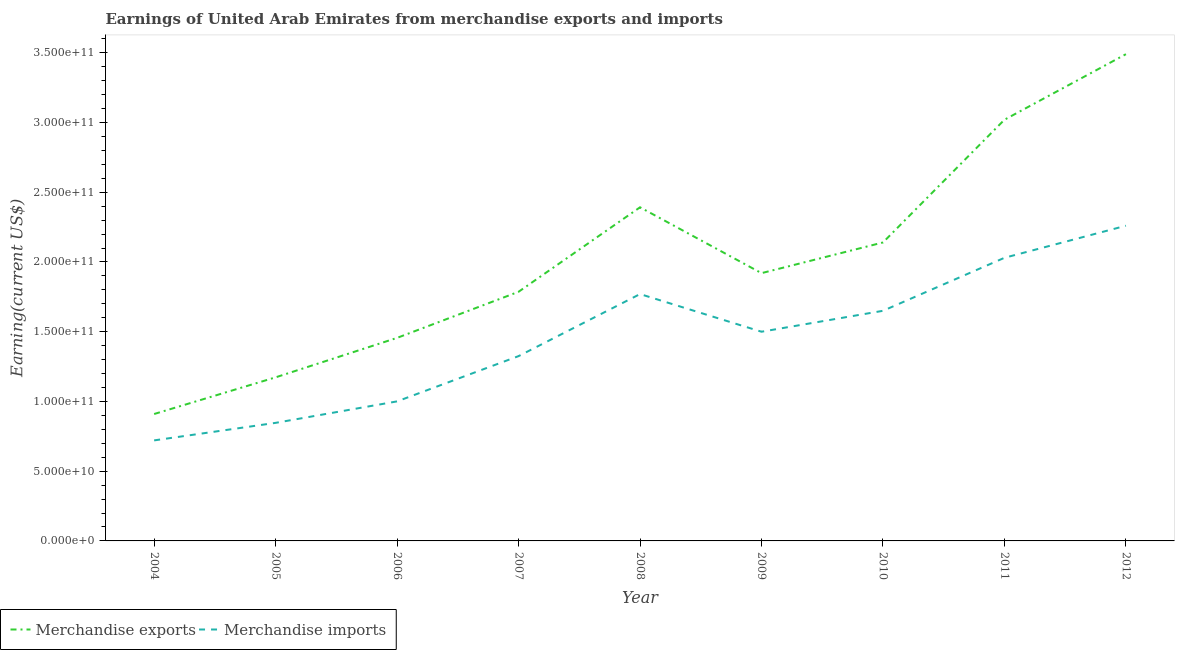How many different coloured lines are there?
Ensure brevity in your answer.  2. Does the line corresponding to earnings from merchandise exports intersect with the line corresponding to earnings from merchandise imports?
Make the answer very short. No. Is the number of lines equal to the number of legend labels?
Keep it short and to the point. Yes. What is the earnings from merchandise imports in 2006?
Provide a short and direct response. 1.00e+11. Across all years, what is the maximum earnings from merchandise exports?
Make the answer very short. 3.49e+11. Across all years, what is the minimum earnings from merchandise imports?
Provide a short and direct response. 7.21e+1. In which year was the earnings from merchandise exports maximum?
Provide a succinct answer. 2012. In which year was the earnings from merchandise imports minimum?
Provide a succinct answer. 2004. What is the total earnings from merchandise exports in the graph?
Your answer should be compact. 1.83e+12. What is the difference between the earnings from merchandise imports in 2004 and that in 2010?
Provide a succinct answer. -9.29e+1. What is the difference between the earnings from merchandise imports in 2012 and the earnings from merchandise exports in 2008?
Provide a short and direct response. -1.32e+1. What is the average earnings from merchandise exports per year?
Give a very brief answer. 2.03e+11. In the year 2008, what is the difference between the earnings from merchandise exports and earnings from merchandise imports?
Provide a short and direct response. 6.22e+1. What is the ratio of the earnings from merchandise exports in 2006 to that in 2007?
Give a very brief answer. 0.82. What is the difference between the highest and the second highest earnings from merchandise imports?
Keep it short and to the point. 2.30e+1. What is the difference between the highest and the lowest earnings from merchandise imports?
Make the answer very short. 1.54e+11. In how many years, is the earnings from merchandise exports greater than the average earnings from merchandise exports taken over all years?
Give a very brief answer. 4. Is the sum of the earnings from merchandise imports in 2007 and 2010 greater than the maximum earnings from merchandise exports across all years?
Your answer should be compact. No. Does the earnings from merchandise imports monotonically increase over the years?
Offer a very short reply. No. What is the difference between two consecutive major ticks on the Y-axis?
Keep it short and to the point. 5.00e+1. How many legend labels are there?
Make the answer very short. 2. How are the legend labels stacked?
Your response must be concise. Horizontal. What is the title of the graph?
Your answer should be very brief. Earnings of United Arab Emirates from merchandise exports and imports. Does "Agricultural land" appear as one of the legend labels in the graph?
Ensure brevity in your answer.  No. What is the label or title of the X-axis?
Make the answer very short. Year. What is the label or title of the Y-axis?
Offer a very short reply. Earning(current US$). What is the Earning(current US$) in Merchandise exports in 2004?
Offer a terse response. 9.10e+1. What is the Earning(current US$) of Merchandise imports in 2004?
Your answer should be very brief. 7.21e+1. What is the Earning(current US$) of Merchandise exports in 2005?
Give a very brief answer. 1.17e+11. What is the Earning(current US$) in Merchandise imports in 2005?
Your response must be concise. 8.47e+1. What is the Earning(current US$) of Merchandise exports in 2006?
Keep it short and to the point. 1.46e+11. What is the Earning(current US$) in Merchandise imports in 2006?
Offer a very short reply. 1.00e+11. What is the Earning(current US$) in Merchandise exports in 2007?
Give a very brief answer. 1.79e+11. What is the Earning(current US$) in Merchandise imports in 2007?
Make the answer very short. 1.32e+11. What is the Earning(current US$) in Merchandise exports in 2008?
Provide a short and direct response. 2.39e+11. What is the Earning(current US$) in Merchandise imports in 2008?
Provide a succinct answer. 1.77e+11. What is the Earning(current US$) in Merchandise exports in 2009?
Give a very brief answer. 1.92e+11. What is the Earning(current US$) in Merchandise imports in 2009?
Offer a terse response. 1.50e+11. What is the Earning(current US$) in Merchandise exports in 2010?
Ensure brevity in your answer.  2.14e+11. What is the Earning(current US$) in Merchandise imports in 2010?
Your answer should be very brief. 1.65e+11. What is the Earning(current US$) in Merchandise exports in 2011?
Provide a short and direct response. 3.02e+11. What is the Earning(current US$) in Merchandise imports in 2011?
Make the answer very short. 2.03e+11. What is the Earning(current US$) in Merchandise exports in 2012?
Provide a succinct answer. 3.49e+11. What is the Earning(current US$) in Merchandise imports in 2012?
Provide a short and direct response. 2.26e+11. Across all years, what is the maximum Earning(current US$) in Merchandise exports?
Provide a short and direct response. 3.49e+11. Across all years, what is the maximum Earning(current US$) of Merchandise imports?
Make the answer very short. 2.26e+11. Across all years, what is the minimum Earning(current US$) in Merchandise exports?
Offer a very short reply. 9.10e+1. Across all years, what is the minimum Earning(current US$) of Merchandise imports?
Give a very brief answer. 7.21e+1. What is the total Earning(current US$) of Merchandise exports in the graph?
Keep it short and to the point. 1.83e+12. What is the total Earning(current US$) in Merchandise imports in the graph?
Provide a succinct answer. 1.31e+12. What is the difference between the Earning(current US$) of Merchandise exports in 2004 and that in 2005?
Offer a terse response. -2.63e+1. What is the difference between the Earning(current US$) in Merchandise imports in 2004 and that in 2005?
Offer a terse response. -1.26e+1. What is the difference between the Earning(current US$) in Merchandise exports in 2004 and that in 2006?
Provide a succinct answer. -5.46e+1. What is the difference between the Earning(current US$) of Merchandise imports in 2004 and that in 2006?
Give a very brief answer. -2.80e+1. What is the difference between the Earning(current US$) of Merchandise exports in 2004 and that in 2007?
Offer a very short reply. -8.76e+1. What is the difference between the Earning(current US$) of Merchandise imports in 2004 and that in 2007?
Ensure brevity in your answer.  -6.04e+1. What is the difference between the Earning(current US$) in Merchandise exports in 2004 and that in 2008?
Your response must be concise. -1.48e+11. What is the difference between the Earning(current US$) of Merchandise imports in 2004 and that in 2008?
Give a very brief answer. -1.05e+11. What is the difference between the Earning(current US$) of Merchandise exports in 2004 and that in 2009?
Ensure brevity in your answer.  -1.01e+11. What is the difference between the Earning(current US$) in Merchandise imports in 2004 and that in 2009?
Give a very brief answer. -7.79e+1. What is the difference between the Earning(current US$) of Merchandise exports in 2004 and that in 2010?
Offer a terse response. -1.23e+11. What is the difference between the Earning(current US$) of Merchandise imports in 2004 and that in 2010?
Keep it short and to the point. -9.29e+1. What is the difference between the Earning(current US$) of Merchandise exports in 2004 and that in 2011?
Provide a succinct answer. -2.11e+11. What is the difference between the Earning(current US$) in Merchandise imports in 2004 and that in 2011?
Give a very brief answer. -1.31e+11. What is the difference between the Earning(current US$) in Merchandise exports in 2004 and that in 2012?
Offer a very short reply. -2.58e+11. What is the difference between the Earning(current US$) of Merchandise imports in 2004 and that in 2012?
Give a very brief answer. -1.54e+11. What is the difference between the Earning(current US$) of Merchandise exports in 2005 and that in 2006?
Ensure brevity in your answer.  -2.83e+1. What is the difference between the Earning(current US$) of Merchandise imports in 2005 and that in 2006?
Your answer should be very brief. -1.54e+1. What is the difference between the Earning(current US$) in Merchandise exports in 2005 and that in 2007?
Give a very brief answer. -6.13e+1. What is the difference between the Earning(current US$) in Merchandise imports in 2005 and that in 2007?
Your response must be concise. -4.78e+1. What is the difference between the Earning(current US$) of Merchandise exports in 2005 and that in 2008?
Your answer should be compact. -1.22e+11. What is the difference between the Earning(current US$) in Merchandise imports in 2005 and that in 2008?
Provide a short and direct response. -9.23e+1. What is the difference between the Earning(current US$) of Merchandise exports in 2005 and that in 2009?
Offer a very short reply. -7.47e+1. What is the difference between the Earning(current US$) in Merchandise imports in 2005 and that in 2009?
Offer a terse response. -6.53e+1. What is the difference between the Earning(current US$) of Merchandise exports in 2005 and that in 2010?
Make the answer very short. -9.67e+1. What is the difference between the Earning(current US$) in Merchandise imports in 2005 and that in 2010?
Give a very brief answer. -8.03e+1. What is the difference between the Earning(current US$) in Merchandise exports in 2005 and that in 2011?
Ensure brevity in your answer.  -1.85e+11. What is the difference between the Earning(current US$) of Merchandise imports in 2005 and that in 2011?
Your answer should be compact. -1.18e+11. What is the difference between the Earning(current US$) of Merchandise exports in 2005 and that in 2012?
Keep it short and to the point. -2.32e+11. What is the difference between the Earning(current US$) in Merchandise imports in 2005 and that in 2012?
Offer a very short reply. -1.41e+11. What is the difference between the Earning(current US$) of Merchandise exports in 2006 and that in 2007?
Provide a short and direct response. -3.30e+1. What is the difference between the Earning(current US$) in Merchandise imports in 2006 and that in 2007?
Provide a succinct answer. -3.24e+1. What is the difference between the Earning(current US$) of Merchandise exports in 2006 and that in 2008?
Give a very brief answer. -9.36e+1. What is the difference between the Earning(current US$) in Merchandise imports in 2006 and that in 2008?
Your answer should be very brief. -7.69e+1. What is the difference between the Earning(current US$) of Merchandise exports in 2006 and that in 2009?
Your response must be concise. -4.64e+1. What is the difference between the Earning(current US$) of Merchandise imports in 2006 and that in 2009?
Offer a terse response. -4.99e+1. What is the difference between the Earning(current US$) in Merchandise exports in 2006 and that in 2010?
Provide a short and direct response. -6.84e+1. What is the difference between the Earning(current US$) in Merchandise imports in 2006 and that in 2010?
Make the answer very short. -6.49e+1. What is the difference between the Earning(current US$) of Merchandise exports in 2006 and that in 2011?
Provide a short and direct response. -1.56e+11. What is the difference between the Earning(current US$) in Merchandise imports in 2006 and that in 2011?
Give a very brief answer. -1.03e+11. What is the difference between the Earning(current US$) in Merchandise exports in 2006 and that in 2012?
Ensure brevity in your answer.  -2.03e+11. What is the difference between the Earning(current US$) in Merchandise imports in 2006 and that in 2012?
Your response must be concise. -1.26e+11. What is the difference between the Earning(current US$) in Merchandise exports in 2007 and that in 2008?
Provide a short and direct response. -6.06e+1. What is the difference between the Earning(current US$) of Merchandise imports in 2007 and that in 2008?
Provide a short and direct response. -4.45e+1. What is the difference between the Earning(current US$) of Merchandise exports in 2007 and that in 2009?
Your response must be concise. -1.34e+1. What is the difference between the Earning(current US$) in Merchandise imports in 2007 and that in 2009?
Provide a short and direct response. -1.75e+1. What is the difference between the Earning(current US$) in Merchandise exports in 2007 and that in 2010?
Your answer should be very brief. -3.54e+1. What is the difference between the Earning(current US$) of Merchandise imports in 2007 and that in 2010?
Your response must be concise. -3.25e+1. What is the difference between the Earning(current US$) of Merchandise exports in 2007 and that in 2011?
Keep it short and to the point. -1.23e+11. What is the difference between the Earning(current US$) in Merchandise imports in 2007 and that in 2011?
Offer a very short reply. -7.05e+1. What is the difference between the Earning(current US$) in Merchandise exports in 2007 and that in 2012?
Your response must be concise. -1.70e+11. What is the difference between the Earning(current US$) of Merchandise imports in 2007 and that in 2012?
Keep it short and to the point. -9.35e+1. What is the difference between the Earning(current US$) in Merchandise exports in 2008 and that in 2009?
Your answer should be very brief. 4.72e+1. What is the difference between the Earning(current US$) of Merchandise imports in 2008 and that in 2009?
Give a very brief answer. 2.70e+1. What is the difference between the Earning(current US$) in Merchandise exports in 2008 and that in 2010?
Offer a terse response. 2.52e+1. What is the difference between the Earning(current US$) in Merchandise imports in 2008 and that in 2010?
Offer a very short reply. 1.20e+1. What is the difference between the Earning(current US$) in Merchandise exports in 2008 and that in 2011?
Ensure brevity in your answer.  -6.28e+1. What is the difference between the Earning(current US$) of Merchandise imports in 2008 and that in 2011?
Offer a very short reply. -2.60e+1. What is the difference between the Earning(current US$) in Merchandise exports in 2008 and that in 2012?
Offer a very short reply. -1.10e+11. What is the difference between the Earning(current US$) in Merchandise imports in 2008 and that in 2012?
Ensure brevity in your answer.  -4.90e+1. What is the difference between the Earning(current US$) of Merchandise exports in 2009 and that in 2010?
Provide a short and direct response. -2.20e+1. What is the difference between the Earning(current US$) in Merchandise imports in 2009 and that in 2010?
Keep it short and to the point. -1.50e+1. What is the difference between the Earning(current US$) of Merchandise exports in 2009 and that in 2011?
Provide a short and direct response. -1.10e+11. What is the difference between the Earning(current US$) of Merchandise imports in 2009 and that in 2011?
Provide a short and direct response. -5.30e+1. What is the difference between the Earning(current US$) of Merchandise exports in 2009 and that in 2012?
Provide a short and direct response. -1.57e+11. What is the difference between the Earning(current US$) of Merchandise imports in 2009 and that in 2012?
Your response must be concise. -7.60e+1. What is the difference between the Earning(current US$) of Merchandise exports in 2010 and that in 2011?
Offer a very short reply. -8.80e+1. What is the difference between the Earning(current US$) of Merchandise imports in 2010 and that in 2011?
Your response must be concise. -3.80e+1. What is the difference between the Earning(current US$) of Merchandise exports in 2010 and that in 2012?
Give a very brief answer. -1.35e+11. What is the difference between the Earning(current US$) in Merchandise imports in 2010 and that in 2012?
Make the answer very short. -6.10e+1. What is the difference between the Earning(current US$) of Merchandise exports in 2011 and that in 2012?
Your answer should be very brief. -4.70e+1. What is the difference between the Earning(current US$) in Merchandise imports in 2011 and that in 2012?
Offer a very short reply. -2.30e+1. What is the difference between the Earning(current US$) of Merchandise exports in 2004 and the Earning(current US$) of Merchandise imports in 2005?
Make the answer very short. 6.34e+09. What is the difference between the Earning(current US$) of Merchandise exports in 2004 and the Earning(current US$) of Merchandise imports in 2006?
Provide a succinct answer. -9.06e+09. What is the difference between the Earning(current US$) in Merchandise exports in 2004 and the Earning(current US$) in Merchandise imports in 2007?
Give a very brief answer. -4.15e+1. What is the difference between the Earning(current US$) of Merchandise exports in 2004 and the Earning(current US$) of Merchandise imports in 2008?
Provide a succinct answer. -8.60e+1. What is the difference between the Earning(current US$) of Merchandise exports in 2004 and the Earning(current US$) of Merchandise imports in 2009?
Your response must be concise. -5.90e+1. What is the difference between the Earning(current US$) in Merchandise exports in 2004 and the Earning(current US$) in Merchandise imports in 2010?
Offer a very short reply. -7.40e+1. What is the difference between the Earning(current US$) in Merchandise exports in 2004 and the Earning(current US$) in Merchandise imports in 2011?
Your response must be concise. -1.12e+11. What is the difference between the Earning(current US$) of Merchandise exports in 2004 and the Earning(current US$) of Merchandise imports in 2012?
Keep it short and to the point. -1.35e+11. What is the difference between the Earning(current US$) of Merchandise exports in 2005 and the Earning(current US$) of Merchandise imports in 2006?
Keep it short and to the point. 1.72e+1. What is the difference between the Earning(current US$) of Merchandise exports in 2005 and the Earning(current US$) of Merchandise imports in 2007?
Offer a terse response. -1.52e+1. What is the difference between the Earning(current US$) in Merchandise exports in 2005 and the Earning(current US$) in Merchandise imports in 2008?
Your answer should be very brief. -5.97e+1. What is the difference between the Earning(current US$) of Merchandise exports in 2005 and the Earning(current US$) of Merchandise imports in 2009?
Offer a very short reply. -3.27e+1. What is the difference between the Earning(current US$) of Merchandise exports in 2005 and the Earning(current US$) of Merchandise imports in 2010?
Ensure brevity in your answer.  -4.77e+1. What is the difference between the Earning(current US$) in Merchandise exports in 2005 and the Earning(current US$) in Merchandise imports in 2011?
Give a very brief answer. -8.57e+1. What is the difference between the Earning(current US$) in Merchandise exports in 2005 and the Earning(current US$) in Merchandise imports in 2012?
Your answer should be very brief. -1.09e+11. What is the difference between the Earning(current US$) in Merchandise exports in 2006 and the Earning(current US$) in Merchandise imports in 2007?
Give a very brief answer. 1.31e+1. What is the difference between the Earning(current US$) in Merchandise exports in 2006 and the Earning(current US$) in Merchandise imports in 2008?
Offer a very short reply. -3.14e+1. What is the difference between the Earning(current US$) in Merchandise exports in 2006 and the Earning(current US$) in Merchandise imports in 2009?
Make the answer very short. -4.41e+09. What is the difference between the Earning(current US$) in Merchandise exports in 2006 and the Earning(current US$) in Merchandise imports in 2010?
Keep it short and to the point. -1.94e+1. What is the difference between the Earning(current US$) in Merchandise exports in 2006 and the Earning(current US$) in Merchandise imports in 2011?
Your response must be concise. -5.74e+1. What is the difference between the Earning(current US$) of Merchandise exports in 2006 and the Earning(current US$) of Merchandise imports in 2012?
Keep it short and to the point. -8.04e+1. What is the difference between the Earning(current US$) in Merchandise exports in 2007 and the Earning(current US$) in Merchandise imports in 2008?
Give a very brief answer. 1.63e+09. What is the difference between the Earning(current US$) of Merchandise exports in 2007 and the Earning(current US$) of Merchandise imports in 2009?
Provide a short and direct response. 2.86e+1. What is the difference between the Earning(current US$) in Merchandise exports in 2007 and the Earning(current US$) in Merchandise imports in 2010?
Provide a short and direct response. 1.36e+1. What is the difference between the Earning(current US$) in Merchandise exports in 2007 and the Earning(current US$) in Merchandise imports in 2011?
Make the answer very short. -2.44e+1. What is the difference between the Earning(current US$) in Merchandise exports in 2007 and the Earning(current US$) in Merchandise imports in 2012?
Provide a short and direct response. -4.74e+1. What is the difference between the Earning(current US$) of Merchandise exports in 2008 and the Earning(current US$) of Merchandise imports in 2009?
Provide a short and direct response. 8.92e+1. What is the difference between the Earning(current US$) in Merchandise exports in 2008 and the Earning(current US$) in Merchandise imports in 2010?
Make the answer very short. 7.42e+1. What is the difference between the Earning(current US$) in Merchandise exports in 2008 and the Earning(current US$) in Merchandise imports in 2011?
Your answer should be very brief. 3.62e+1. What is the difference between the Earning(current US$) in Merchandise exports in 2008 and the Earning(current US$) in Merchandise imports in 2012?
Offer a very short reply. 1.32e+1. What is the difference between the Earning(current US$) in Merchandise exports in 2009 and the Earning(current US$) in Merchandise imports in 2010?
Offer a very short reply. 2.70e+1. What is the difference between the Earning(current US$) in Merchandise exports in 2009 and the Earning(current US$) in Merchandise imports in 2011?
Offer a very short reply. -1.10e+1. What is the difference between the Earning(current US$) in Merchandise exports in 2009 and the Earning(current US$) in Merchandise imports in 2012?
Keep it short and to the point. -3.40e+1. What is the difference between the Earning(current US$) of Merchandise exports in 2010 and the Earning(current US$) of Merchandise imports in 2011?
Keep it short and to the point. 1.10e+1. What is the difference between the Earning(current US$) in Merchandise exports in 2010 and the Earning(current US$) in Merchandise imports in 2012?
Make the answer very short. -1.20e+1. What is the difference between the Earning(current US$) in Merchandise exports in 2011 and the Earning(current US$) in Merchandise imports in 2012?
Offer a terse response. 7.60e+1. What is the average Earning(current US$) of Merchandise exports per year?
Your response must be concise. 2.03e+11. What is the average Earning(current US$) of Merchandise imports per year?
Your response must be concise. 1.46e+11. In the year 2004, what is the difference between the Earning(current US$) in Merchandise exports and Earning(current US$) in Merchandise imports?
Your answer should be very brief. 1.89e+1. In the year 2005, what is the difference between the Earning(current US$) of Merchandise exports and Earning(current US$) of Merchandise imports?
Your answer should be very brief. 3.26e+1. In the year 2006, what is the difference between the Earning(current US$) of Merchandise exports and Earning(current US$) of Merchandise imports?
Keep it short and to the point. 4.55e+1. In the year 2007, what is the difference between the Earning(current US$) in Merchandise exports and Earning(current US$) in Merchandise imports?
Ensure brevity in your answer.  4.61e+1. In the year 2008, what is the difference between the Earning(current US$) in Merchandise exports and Earning(current US$) in Merchandise imports?
Your answer should be compact. 6.22e+1. In the year 2009, what is the difference between the Earning(current US$) in Merchandise exports and Earning(current US$) in Merchandise imports?
Your answer should be compact. 4.20e+1. In the year 2010, what is the difference between the Earning(current US$) in Merchandise exports and Earning(current US$) in Merchandise imports?
Give a very brief answer. 4.90e+1. In the year 2011, what is the difference between the Earning(current US$) in Merchandise exports and Earning(current US$) in Merchandise imports?
Your answer should be very brief. 9.90e+1. In the year 2012, what is the difference between the Earning(current US$) of Merchandise exports and Earning(current US$) of Merchandise imports?
Your answer should be very brief. 1.23e+11. What is the ratio of the Earning(current US$) in Merchandise exports in 2004 to that in 2005?
Your answer should be very brief. 0.78. What is the ratio of the Earning(current US$) of Merchandise imports in 2004 to that in 2005?
Provide a short and direct response. 0.85. What is the ratio of the Earning(current US$) in Merchandise imports in 2004 to that in 2006?
Provide a succinct answer. 0.72. What is the ratio of the Earning(current US$) in Merchandise exports in 2004 to that in 2007?
Keep it short and to the point. 0.51. What is the ratio of the Earning(current US$) of Merchandise imports in 2004 to that in 2007?
Provide a short and direct response. 0.54. What is the ratio of the Earning(current US$) of Merchandise exports in 2004 to that in 2008?
Ensure brevity in your answer.  0.38. What is the ratio of the Earning(current US$) of Merchandise imports in 2004 to that in 2008?
Provide a short and direct response. 0.41. What is the ratio of the Earning(current US$) in Merchandise exports in 2004 to that in 2009?
Your answer should be compact. 0.47. What is the ratio of the Earning(current US$) of Merchandise imports in 2004 to that in 2009?
Ensure brevity in your answer.  0.48. What is the ratio of the Earning(current US$) in Merchandise exports in 2004 to that in 2010?
Ensure brevity in your answer.  0.43. What is the ratio of the Earning(current US$) of Merchandise imports in 2004 to that in 2010?
Ensure brevity in your answer.  0.44. What is the ratio of the Earning(current US$) of Merchandise exports in 2004 to that in 2011?
Make the answer very short. 0.3. What is the ratio of the Earning(current US$) in Merchandise imports in 2004 to that in 2011?
Provide a succinct answer. 0.36. What is the ratio of the Earning(current US$) in Merchandise exports in 2004 to that in 2012?
Provide a succinct answer. 0.26. What is the ratio of the Earning(current US$) of Merchandise imports in 2004 to that in 2012?
Offer a very short reply. 0.32. What is the ratio of the Earning(current US$) of Merchandise exports in 2005 to that in 2006?
Make the answer very short. 0.81. What is the ratio of the Earning(current US$) in Merchandise imports in 2005 to that in 2006?
Provide a succinct answer. 0.85. What is the ratio of the Earning(current US$) in Merchandise exports in 2005 to that in 2007?
Make the answer very short. 0.66. What is the ratio of the Earning(current US$) of Merchandise imports in 2005 to that in 2007?
Provide a short and direct response. 0.64. What is the ratio of the Earning(current US$) of Merchandise exports in 2005 to that in 2008?
Offer a very short reply. 0.49. What is the ratio of the Earning(current US$) in Merchandise imports in 2005 to that in 2008?
Keep it short and to the point. 0.48. What is the ratio of the Earning(current US$) in Merchandise exports in 2005 to that in 2009?
Make the answer very short. 0.61. What is the ratio of the Earning(current US$) of Merchandise imports in 2005 to that in 2009?
Your answer should be very brief. 0.56. What is the ratio of the Earning(current US$) in Merchandise exports in 2005 to that in 2010?
Your response must be concise. 0.55. What is the ratio of the Earning(current US$) in Merchandise imports in 2005 to that in 2010?
Provide a short and direct response. 0.51. What is the ratio of the Earning(current US$) in Merchandise exports in 2005 to that in 2011?
Your answer should be very brief. 0.39. What is the ratio of the Earning(current US$) of Merchandise imports in 2005 to that in 2011?
Provide a short and direct response. 0.42. What is the ratio of the Earning(current US$) in Merchandise exports in 2005 to that in 2012?
Your response must be concise. 0.34. What is the ratio of the Earning(current US$) of Merchandise imports in 2005 to that in 2012?
Offer a terse response. 0.37. What is the ratio of the Earning(current US$) of Merchandise exports in 2006 to that in 2007?
Keep it short and to the point. 0.81. What is the ratio of the Earning(current US$) of Merchandise imports in 2006 to that in 2007?
Make the answer very short. 0.76. What is the ratio of the Earning(current US$) of Merchandise exports in 2006 to that in 2008?
Make the answer very short. 0.61. What is the ratio of the Earning(current US$) of Merchandise imports in 2006 to that in 2008?
Your answer should be very brief. 0.57. What is the ratio of the Earning(current US$) in Merchandise exports in 2006 to that in 2009?
Offer a terse response. 0.76. What is the ratio of the Earning(current US$) in Merchandise imports in 2006 to that in 2009?
Provide a succinct answer. 0.67. What is the ratio of the Earning(current US$) in Merchandise exports in 2006 to that in 2010?
Ensure brevity in your answer.  0.68. What is the ratio of the Earning(current US$) in Merchandise imports in 2006 to that in 2010?
Make the answer very short. 0.61. What is the ratio of the Earning(current US$) of Merchandise exports in 2006 to that in 2011?
Offer a very short reply. 0.48. What is the ratio of the Earning(current US$) of Merchandise imports in 2006 to that in 2011?
Give a very brief answer. 0.49. What is the ratio of the Earning(current US$) of Merchandise exports in 2006 to that in 2012?
Provide a short and direct response. 0.42. What is the ratio of the Earning(current US$) in Merchandise imports in 2006 to that in 2012?
Keep it short and to the point. 0.44. What is the ratio of the Earning(current US$) of Merchandise exports in 2007 to that in 2008?
Offer a very short reply. 0.75. What is the ratio of the Earning(current US$) of Merchandise imports in 2007 to that in 2008?
Give a very brief answer. 0.75. What is the ratio of the Earning(current US$) of Merchandise exports in 2007 to that in 2009?
Ensure brevity in your answer.  0.93. What is the ratio of the Earning(current US$) of Merchandise imports in 2007 to that in 2009?
Ensure brevity in your answer.  0.88. What is the ratio of the Earning(current US$) of Merchandise exports in 2007 to that in 2010?
Your answer should be compact. 0.83. What is the ratio of the Earning(current US$) in Merchandise imports in 2007 to that in 2010?
Make the answer very short. 0.8. What is the ratio of the Earning(current US$) in Merchandise exports in 2007 to that in 2011?
Ensure brevity in your answer.  0.59. What is the ratio of the Earning(current US$) in Merchandise imports in 2007 to that in 2011?
Give a very brief answer. 0.65. What is the ratio of the Earning(current US$) of Merchandise exports in 2007 to that in 2012?
Your answer should be compact. 0.51. What is the ratio of the Earning(current US$) in Merchandise imports in 2007 to that in 2012?
Offer a terse response. 0.59. What is the ratio of the Earning(current US$) of Merchandise exports in 2008 to that in 2009?
Offer a terse response. 1.25. What is the ratio of the Earning(current US$) in Merchandise imports in 2008 to that in 2009?
Make the answer very short. 1.18. What is the ratio of the Earning(current US$) in Merchandise exports in 2008 to that in 2010?
Provide a short and direct response. 1.12. What is the ratio of the Earning(current US$) of Merchandise imports in 2008 to that in 2010?
Your answer should be compact. 1.07. What is the ratio of the Earning(current US$) of Merchandise exports in 2008 to that in 2011?
Your answer should be very brief. 0.79. What is the ratio of the Earning(current US$) of Merchandise imports in 2008 to that in 2011?
Offer a very short reply. 0.87. What is the ratio of the Earning(current US$) of Merchandise exports in 2008 to that in 2012?
Provide a short and direct response. 0.69. What is the ratio of the Earning(current US$) of Merchandise imports in 2008 to that in 2012?
Provide a short and direct response. 0.78. What is the ratio of the Earning(current US$) in Merchandise exports in 2009 to that in 2010?
Ensure brevity in your answer.  0.9. What is the ratio of the Earning(current US$) in Merchandise exports in 2009 to that in 2011?
Your answer should be very brief. 0.64. What is the ratio of the Earning(current US$) of Merchandise imports in 2009 to that in 2011?
Keep it short and to the point. 0.74. What is the ratio of the Earning(current US$) of Merchandise exports in 2009 to that in 2012?
Offer a terse response. 0.55. What is the ratio of the Earning(current US$) in Merchandise imports in 2009 to that in 2012?
Provide a succinct answer. 0.66. What is the ratio of the Earning(current US$) of Merchandise exports in 2010 to that in 2011?
Your response must be concise. 0.71. What is the ratio of the Earning(current US$) in Merchandise imports in 2010 to that in 2011?
Make the answer very short. 0.81. What is the ratio of the Earning(current US$) of Merchandise exports in 2010 to that in 2012?
Your answer should be compact. 0.61. What is the ratio of the Earning(current US$) in Merchandise imports in 2010 to that in 2012?
Your response must be concise. 0.73. What is the ratio of the Earning(current US$) in Merchandise exports in 2011 to that in 2012?
Your answer should be compact. 0.87. What is the ratio of the Earning(current US$) in Merchandise imports in 2011 to that in 2012?
Keep it short and to the point. 0.9. What is the difference between the highest and the second highest Earning(current US$) of Merchandise exports?
Give a very brief answer. 4.70e+1. What is the difference between the highest and the second highest Earning(current US$) in Merchandise imports?
Provide a succinct answer. 2.30e+1. What is the difference between the highest and the lowest Earning(current US$) in Merchandise exports?
Your answer should be very brief. 2.58e+11. What is the difference between the highest and the lowest Earning(current US$) of Merchandise imports?
Provide a short and direct response. 1.54e+11. 